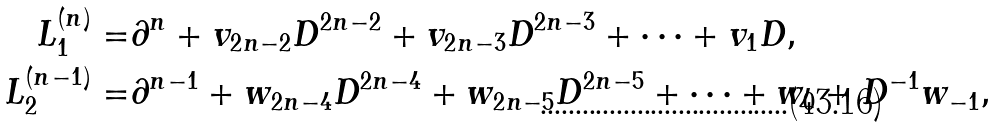Convert formula to latex. <formula><loc_0><loc_0><loc_500><loc_500>L _ { 1 } ^ { ( n ) } = & \partial ^ { n } + v _ { 2 n - 2 } D ^ { 2 n - 2 } + v _ { 2 n - 3 } D ^ { 2 n - 3 } + \dots + v _ { 1 } D , \\ L _ { 2 } ^ { ( n - 1 ) } = & \partial ^ { n - 1 } + w _ { 2 n - 4 } D ^ { 2 n - 4 } + w _ { 2 n - 5 } D ^ { 2 n - 5 } + \dots + w _ { 0 } + D ^ { - 1 } w _ { - 1 } ,</formula> 